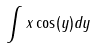<formula> <loc_0><loc_0><loc_500><loc_500>\int x \cos ( y ) d y</formula> 